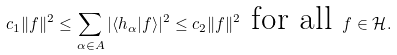<formula> <loc_0><loc_0><loc_500><loc_500>c _ { 1 } \| f \| ^ { 2 } \leq \sum _ { \alpha \in A } | \langle h _ { \alpha } | f \rangle | ^ { 2 } \leq c _ { 2 } \| f \| ^ { 2 } \text { for all } f \in \mathcal { H } .</formula> 